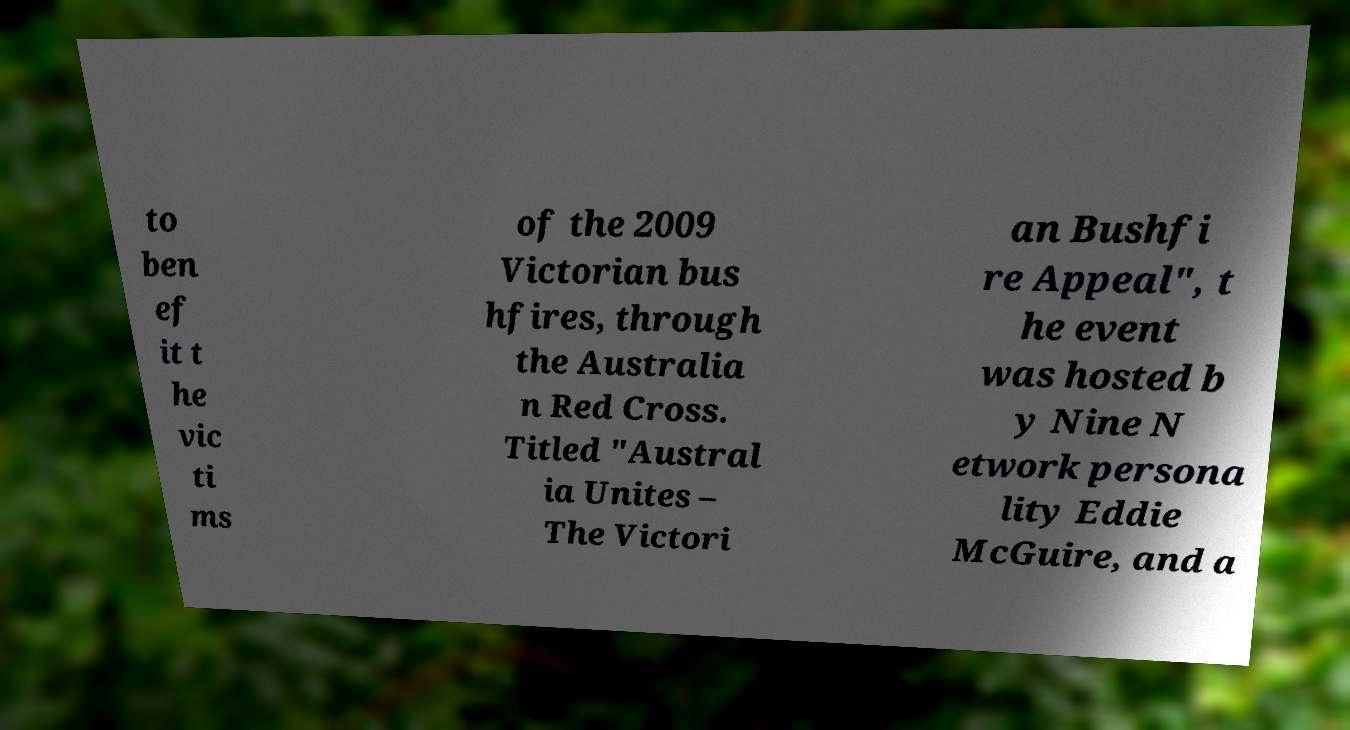For documentation purposes, I need the text within this image transcribed. Could you provide that? to ben ef it t he vic ti ms of the 2009 Victorian bus hfires, through the Australia n Red Cross. Titled "Austral ia Unites – The Victori an Bushfi re Appeal", t he event was hosted b y Nine N etwork persona lity Eddie McGuire, and a 